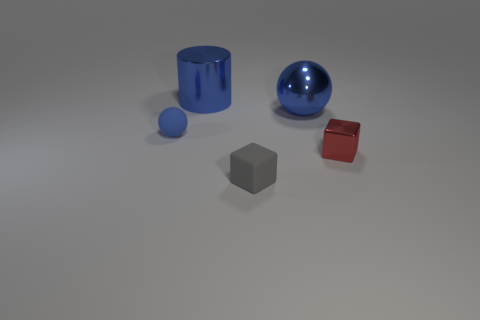Are there any red blocks that are in front of the big blue metallic object left of the small gray object?
Provide a succinct answer. Yes. Does the matte object in front of the blue rubber thing have the same color as the rubber thing that is behind the tiny red block?
Your answer should be very brief. No. The small matte block has what color?
Make the answer very short. Gray. Is there any other thing of the same color as the large cylinder?
Offer a terse response. Yes. What is the color of the thing that is both behind the blue matte object and on the right side of the metallic cylinder?
Provide a succinct answer. Blue. There is a cube on the left side of the red shiny thing; does it have the same size as the blue matte object?
Your answer should be compact. Yes. Are there more big spheres in front of the small blue matte thing than small gray balls?
Offer a very short reply. No. Is the shape of the gray object the same as the blue matte object?
Offer a very short reply. No. The blue cylinder has what size?
Ensure brevity in your answer.  Large. Are there more rubber balls that are on the right side of the gray matte object than big blue shiny things in front of the blue metallic ball?
Your response must be concise. No. 